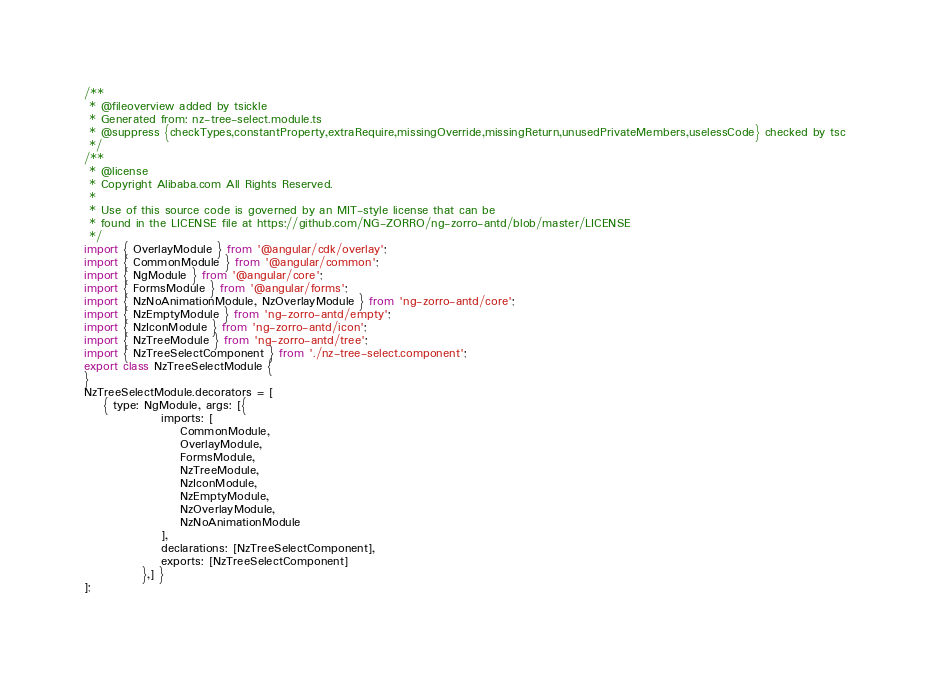<code> <loc_0><loc_0><loc_500><loc_500><_JavaScript_>/**
 * @fileoverview added by tsickle
 * Generated from: nz-tree-select.module.ts
 * @suppress {checkTypes,constantProperty,extraRequire,missingOverride,missingReturn,unusedPrivateMembers,uselessCode} checked by tsc
 */
/**
 * @license
 * Copyright Alibaba.com All Rights Reserved.
 *
 * Use of this source code is governed by an MIT-style license that can be
 * found in the LICENSE file at https://github.com/NG-ZORRO/ng-zorro-antd/blob/master/LICENSE
 */
import { OverlayModule } from '@angular/cdk/overlay';
import { CommonModule } from '@angular/common';
import { NgModule } from '@angular/core';
import { FormsModule } from '@angular/forms';
import { NzNoAnimationModule, NzOverlayModule } from 'ng-zorro-antd/core';
import { NzEmptyModule } from 'ng-zorro-antd/empty';
import { NzIconModule } from 'ng-zorro-antd/icon';
import { NzTreeModule } from 'ng-zorro-antd/tree';
import { NzTreeSelectComponent } from './nz-tree-select.component';
export class NzTreeSelectModule {
}
NzTreeSelectModule.decorators = [
    { type: NgModule, args: [{
                imports: [
                    CommonModule,
                    OverlayModule,
                    FormsModule,
                    NzTreeModule,
                    NzIconModule,
                    NzEmptyModule,
                    NzOverlayModule,
                    NzNoAnimationModule
                ],
                declarations: [NzTreeSelectComponent],
                exports: [NzTreeSelectComponent]
            },] }
];</code> 